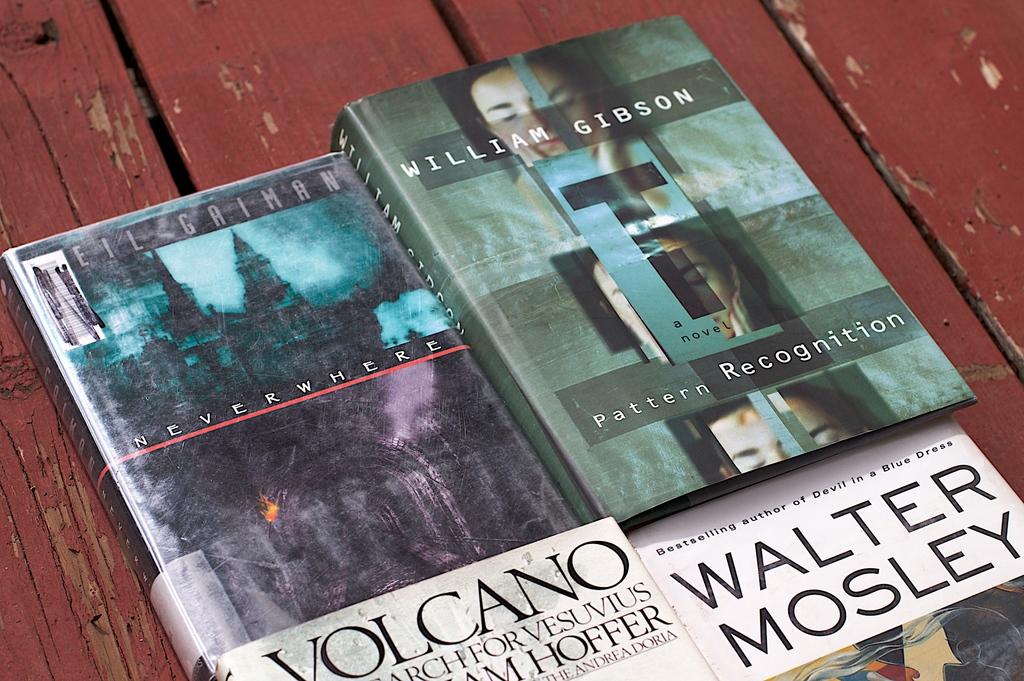Who wrote "pattern recognition"?
Provide a short and direct response. William gibson. What is the title of the left book?
Make the answer very short. Volcano. 